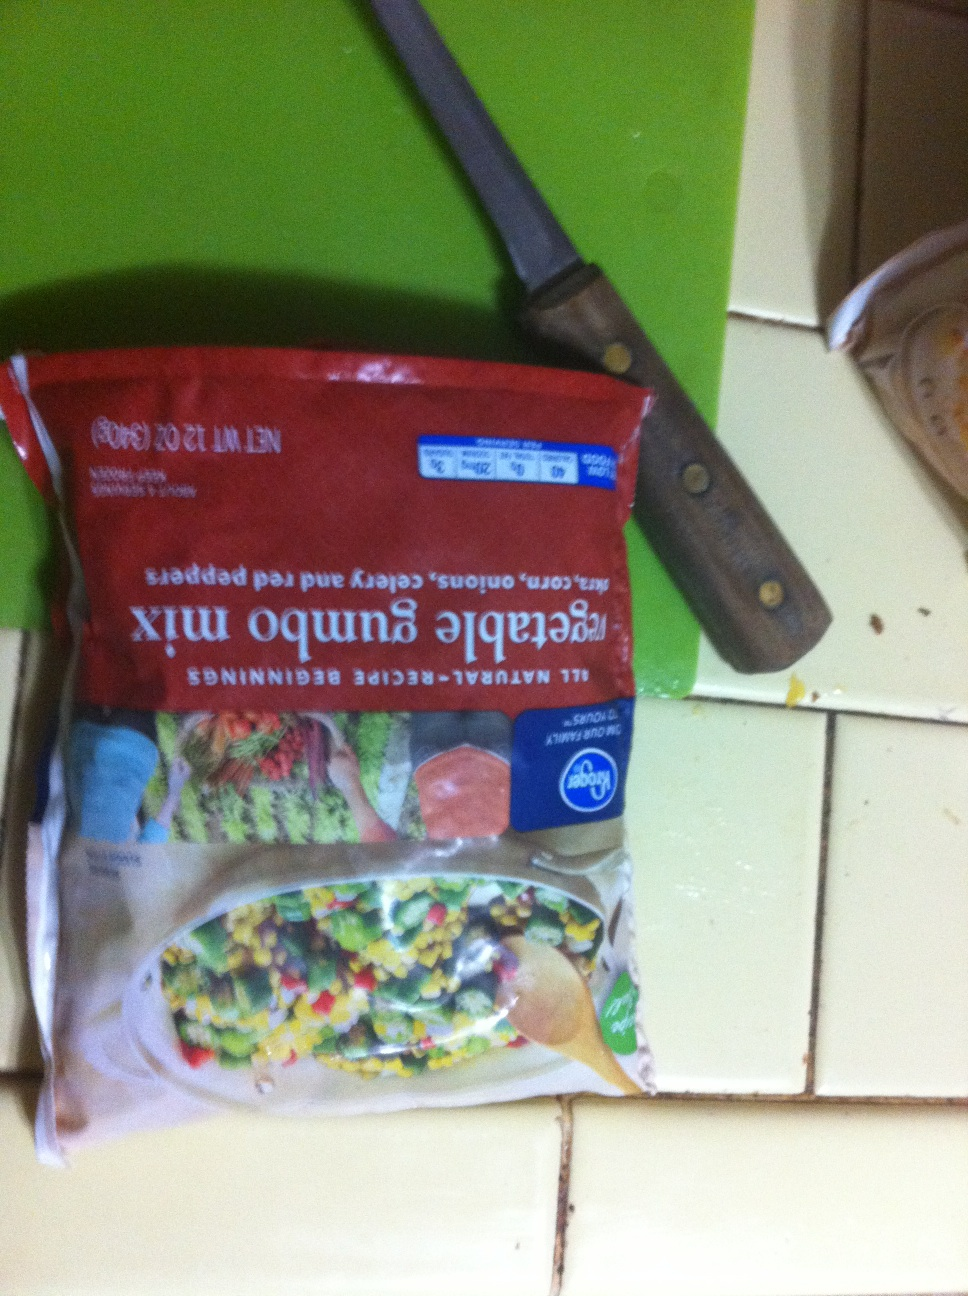Can you list the vegetables that are included in this mix? Certainly! The vegetable gumbo mix includes sweet corn, onions, celery, and red bell peppers. These vegetables are commonly used in making gumbo, a traditional Louisiana dish. How can I use this vegetable mix in a recipe? You can use this vegetable gumbo mix to create a delicious gumbo dish. Start by sautéing the vegetables in a pot with some oil until they are tender. Add in some garlic, spices like thyme, bay leaves, and some flour to make a roux. Slowly add chicken or vegetable broth, and allow the mixture to simmer. Add your choice of protein such as chicken, sausage, or shrimp, and let it cook until everything is well combined and flavorful. Serve over a bed of rice. Enjoy your homemade vegetable gumbo! 